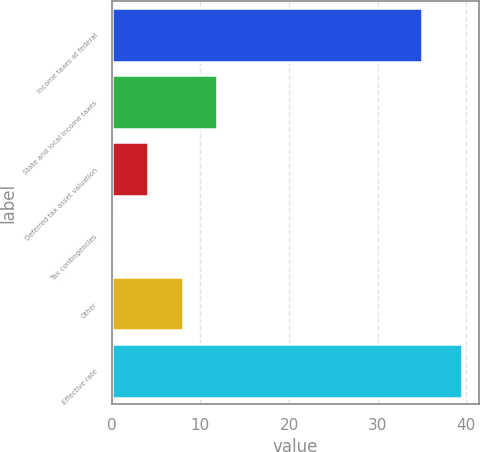Convert chart. <chart><loc_0><loc_0><loc_500><loc_500><bar_chart><fcel>Income taxes at federal<fcel>State and local income taxes<fcel>Deferred tax asset valuation<fcel>Tax contingencies<fcel>Other<fcel>Effective rate<nl><fcel>35<fcel>11.92<fcel>4.04<fcel>0.1<fcel>7.98<fcel>39.5<nl></chart> 